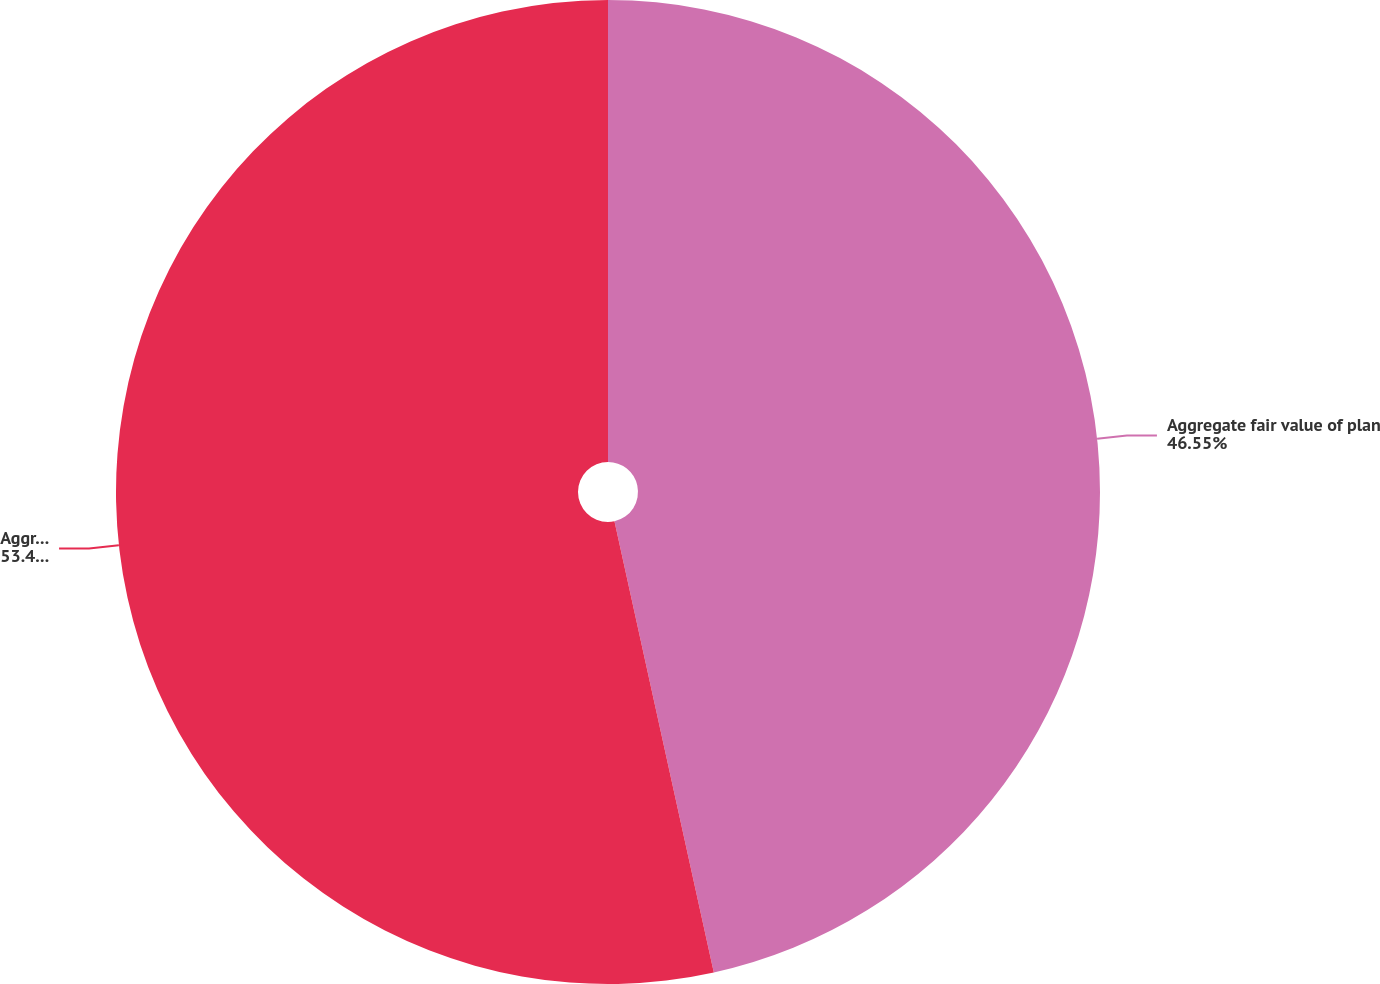<chart> <loc_0><loc_0><loc_500><loc_500><pie_chart><fcel>Aggregate fair value of plan<fcel>Aggregate accumulated benefit<nl><fcel>46.55%<fcel>53.45%<nl></chart> 